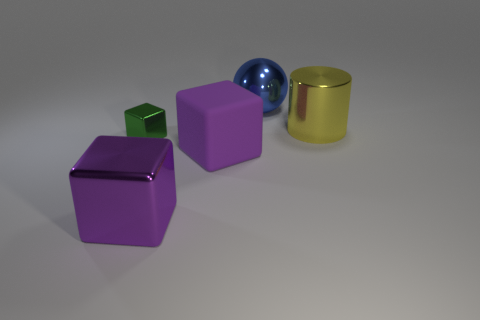Subtract all big blocks. How many blocks are left? 1 Subtract all green blocks. How many blocks are left? 2 Add 5 shiny blocks. How many objects exist? 10 Subtract all cylinders. How many objects are left? 4 Subtract all cyan spheres. How many brown cylinders are left? 0 Subtract all yellow cubes. Subtract all cyan cylinders. How many cubes are left? 3 Subtract all green blocks. Subtract all green metallic cubes. How many objects are left? 3 Add 2 yellow cylinders. How many yellow cylinders are left? 3 Add 4 big yellow matte blocks. How many big yellow matte blocks exist? 4 Subtract 0 yellow spheres. How many objects are left? 5 